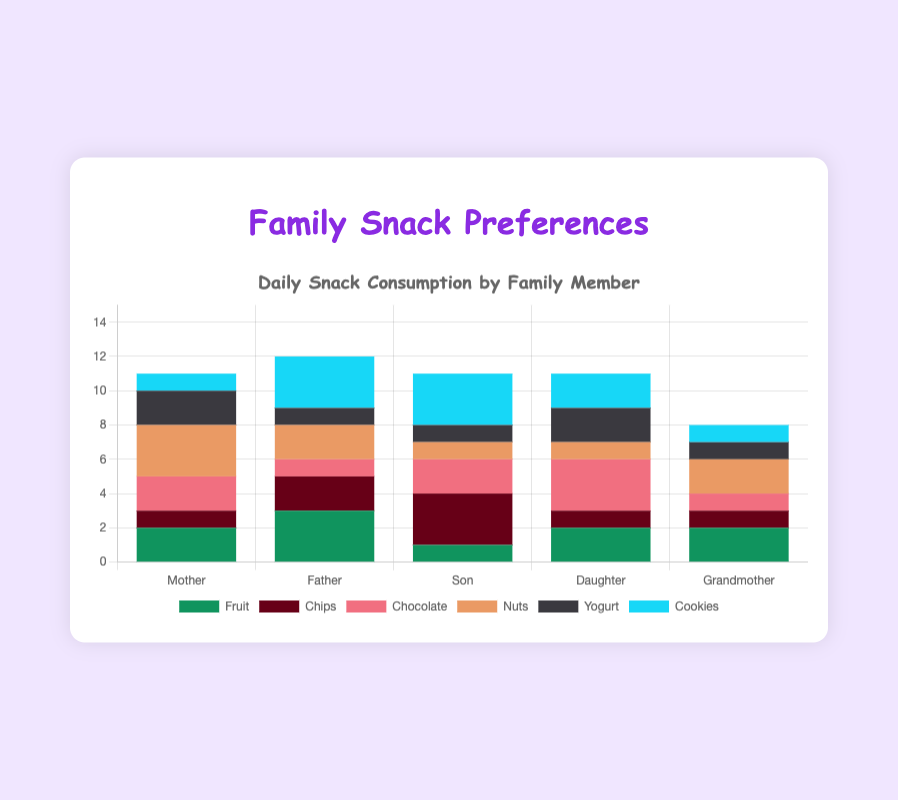How many total snacks does the Mother consume daily? Sum the daily consumption values of all snack types for the Mother: Fruit (2) + Chips (1) + Chocolate (2) + Nuts (3) + Yogurt (2) + Cookies (1) = 11
Answer: 11 Which family member consumes the most cookies daily? Compare the daily consumption of cookies for all family members: Mother (1), Father (3), Son (3), Daughter (2), Grandmother (1). Father and Son both consume 3 cookies daily, the highest amount.
Answer: Father and Son Who consumes more daily, the Mother or the Father? Sum the daily consumption values of all snack types for both the Mother and the Father: Mother (11), Father (12). Compare the totals: 11 < 12.
Answer: Father What is the difference in daily yogurt consumption between the Daughter and the Son? Subtract the Daughter's daily yogurt consumption (2) from the Son's daily yogurt consumption (1): 2 - 1 = 1
Answer: 1 Which snack type does the Son consume the most? Compare the daily consumption values for all snack types for the Son: Fruit (1), Chips (3), Chocolate (2), Nuts (1), Yogurt (1), Cookies (3). Chips and Cookies both have the highest value of 3.
Answer: Chips and Cookies How many more chocolate bars does the Daughter consume compared to the Grandmother? Subtract the Grandmother's daily chocolate consumption (1) from the Daughter's daily chocolate consumption (3): 3 - 1 = 2
Answer: 2 Who has the highest daily consumption of fruit? Compare the daily fruit consumption of all family members: Mother (2), Father (3), Son (1), Daughter (2), Grandmother (2). Father consumes the most with 3.
Answer: Father How much more does the Mother consume nuts daily compared to the Son? Subtract the Son's daily nuts consumption (1) from the Mother's daily nuts consumption (3): 3 - 1 = 2
Answer: 2 What is the average daily consumption of snacks for the Grandmother? Sum all snack consumption values for the Grandmother and divide by the number of snack types: (2 + 1 + 1 + 2 + 1 + 1) / 6 = 8 / 6 ≈ 1.33
Answer: 1.33 Which snack type has the highest total daily consumption among all family members? Sum the daily consumption values for each snack type across all family members: 
Fruit (2+3+1+2+2)=10, 
Chips (1+2+3+1+1)=8, 
Chocolate (2+1+2+3+1)=9, 
Nuts (3+2+1+1+2)=9, 
Yogurt (2+1+1+2+1)=7, 
Cookies (1+3+3+2+1)=10. 
Fruit and Cookies both have the highest total of 10.
Answer: Fruit and Cookies 